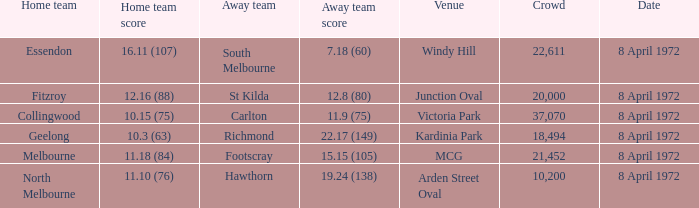Which Home team score has a Home team of geelong? 10.3 (63). 